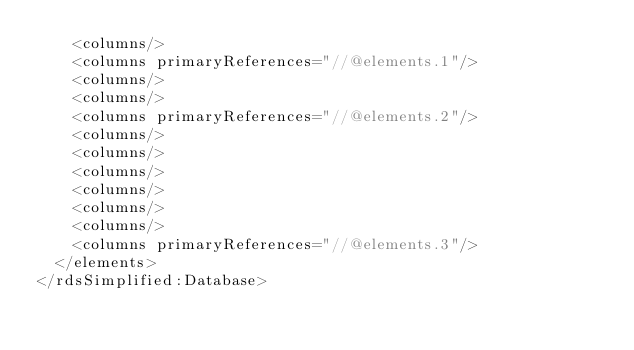Convert code to text. <code><loc_0><loc_0><loc_500><loc_500><_XML_>    <columns/>
    <columns primaryReferences="//@elements.1"/>
    <columns/>
    <columns/>
    <columns primaryReferences="//@elements.2"/>
    <columns/>
    <columns/>
    <columns/>
    <columns/>
    <columns/>
    <columns/>
    <columns primaryReferences="//@elements.3"/>
  </elements>
</rdsSimplified:Database>
</code> 